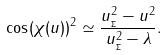Convert formula to latex. <formula><loc_0><loc_0><loc_500><loc_500>\cos ( \chi ( u ) ) ^ { 2 } \simeq \frac { u _ { _ { \Sigma } } ^ { 2 } - u ^ { 2 } } { u _ { _ { \Sigma } } ^ { 2 } - \lambda } .</formula> 